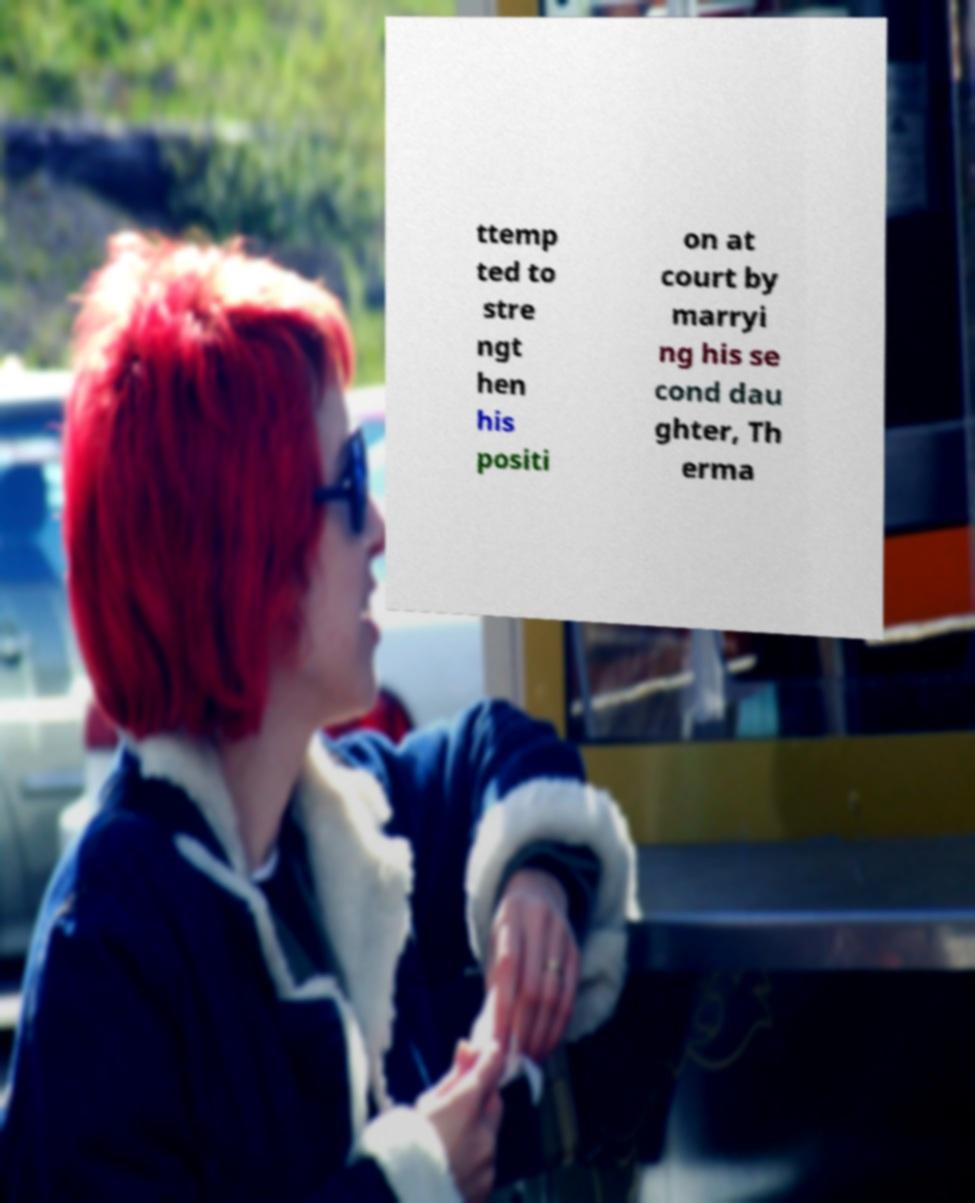For documentation purposes, I need the text within this image transcribed. Could you provide that? ttemp ted to stre ngt hen his positi on at court by marryi ng his se cond dau ghter, Th erma 